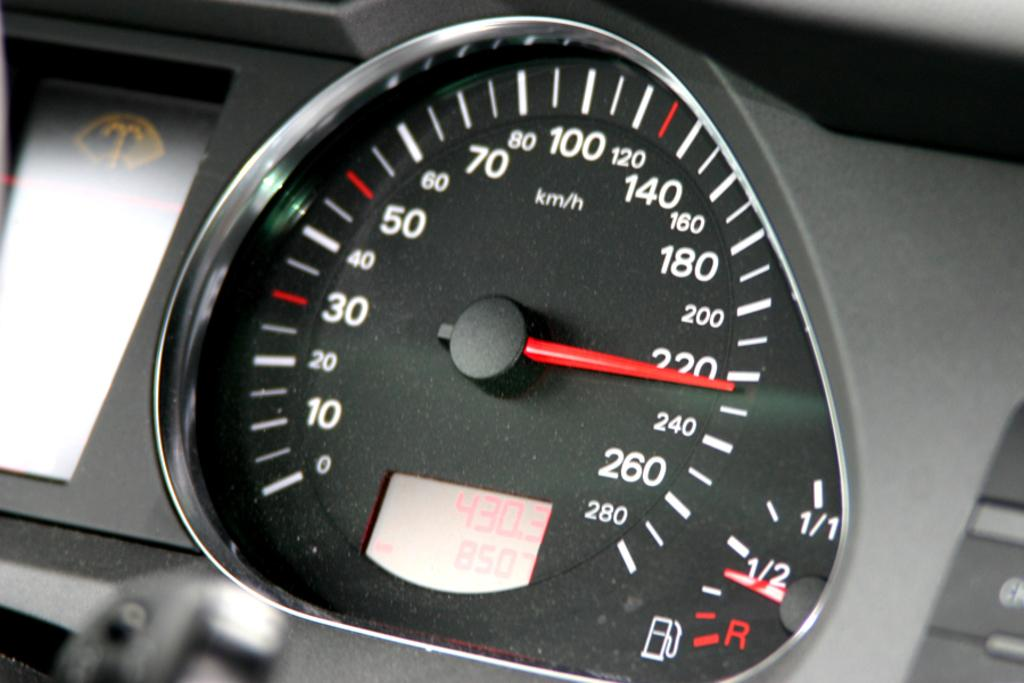What is the main object in the image? There is a display meter in the image. What type of device does the display meter belong to? The display meter belongs to a vehicle. What information can be seen on the display meter? There are numbers and alphabets on the display meter. What type of prison is depicted on the display meter? There is no prison depicted on the display meter; it is a vehicle display meter with numbers and alphabets. 